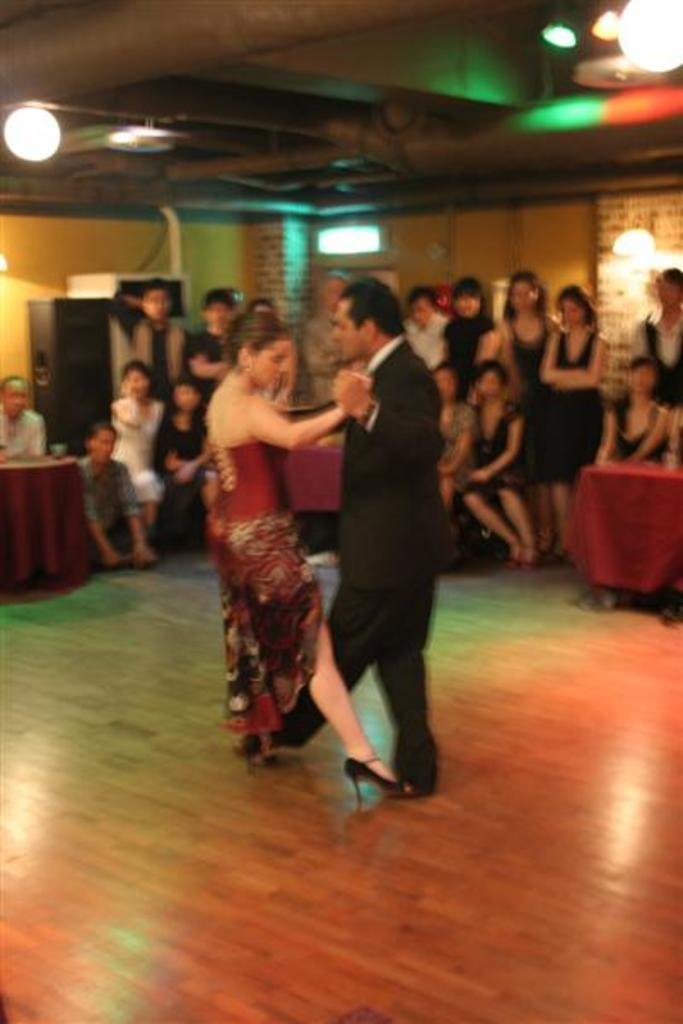How many people can be seen in the image? There are many people in the image. What are the people doing in the image? Couples are dancing in the image. Is there any source of illumination visible in the image? Yes, there is a light visible in the image. How many kittens can be seen playing with boats on the coast in the image? There are no kittens, boats, or coast visible in the image. 